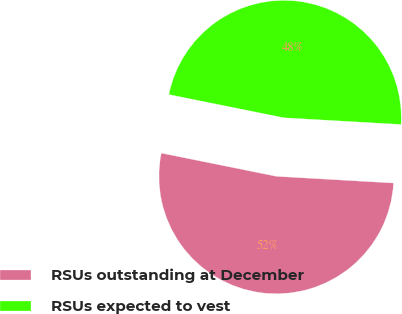Convert chart. <chart><loc_0><loc_0><loc_500><loc_500><pie_chart><fcel>RSUs outstanding at December<fcel>RSUs expected to vest<nl><fcel>52.26%<fcel>47.74%<nl></chart> 